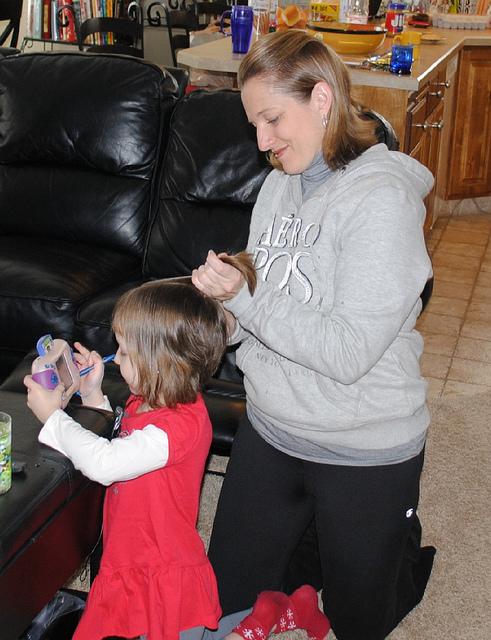Are there tiles visible?
Quick response, please. Yes. What is the color of the little girl's dress?
Quick response, please. Red. What color is the couch?
Answer briefly. Black. 